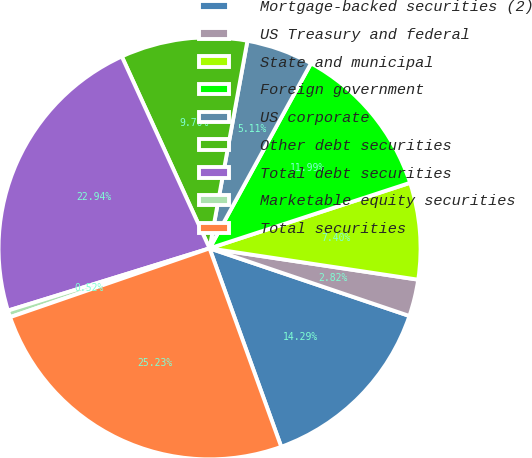Convert chart to OTSL. <chart><loc_0><loc_0><loc_500><loc_500><pie_chart><fcel>Mortgage-backed securities (2)<fcel>US Treasury and federal<fcel>State and municipal<fcel>Foreign government<fcel>US corporate<fcel>Other debt securities<fcel>Total debt securities<fcel>Marketable equity securities<fcel>Total securities<nl><fcel>14.29%<fcel>2.82%<fcel>7.4%<fcel>11.99%<fcel>5.11%<fcel>9.7%<fcel>22.94%<fcel>0.52%<fcel>25.23%<nl></chart> 